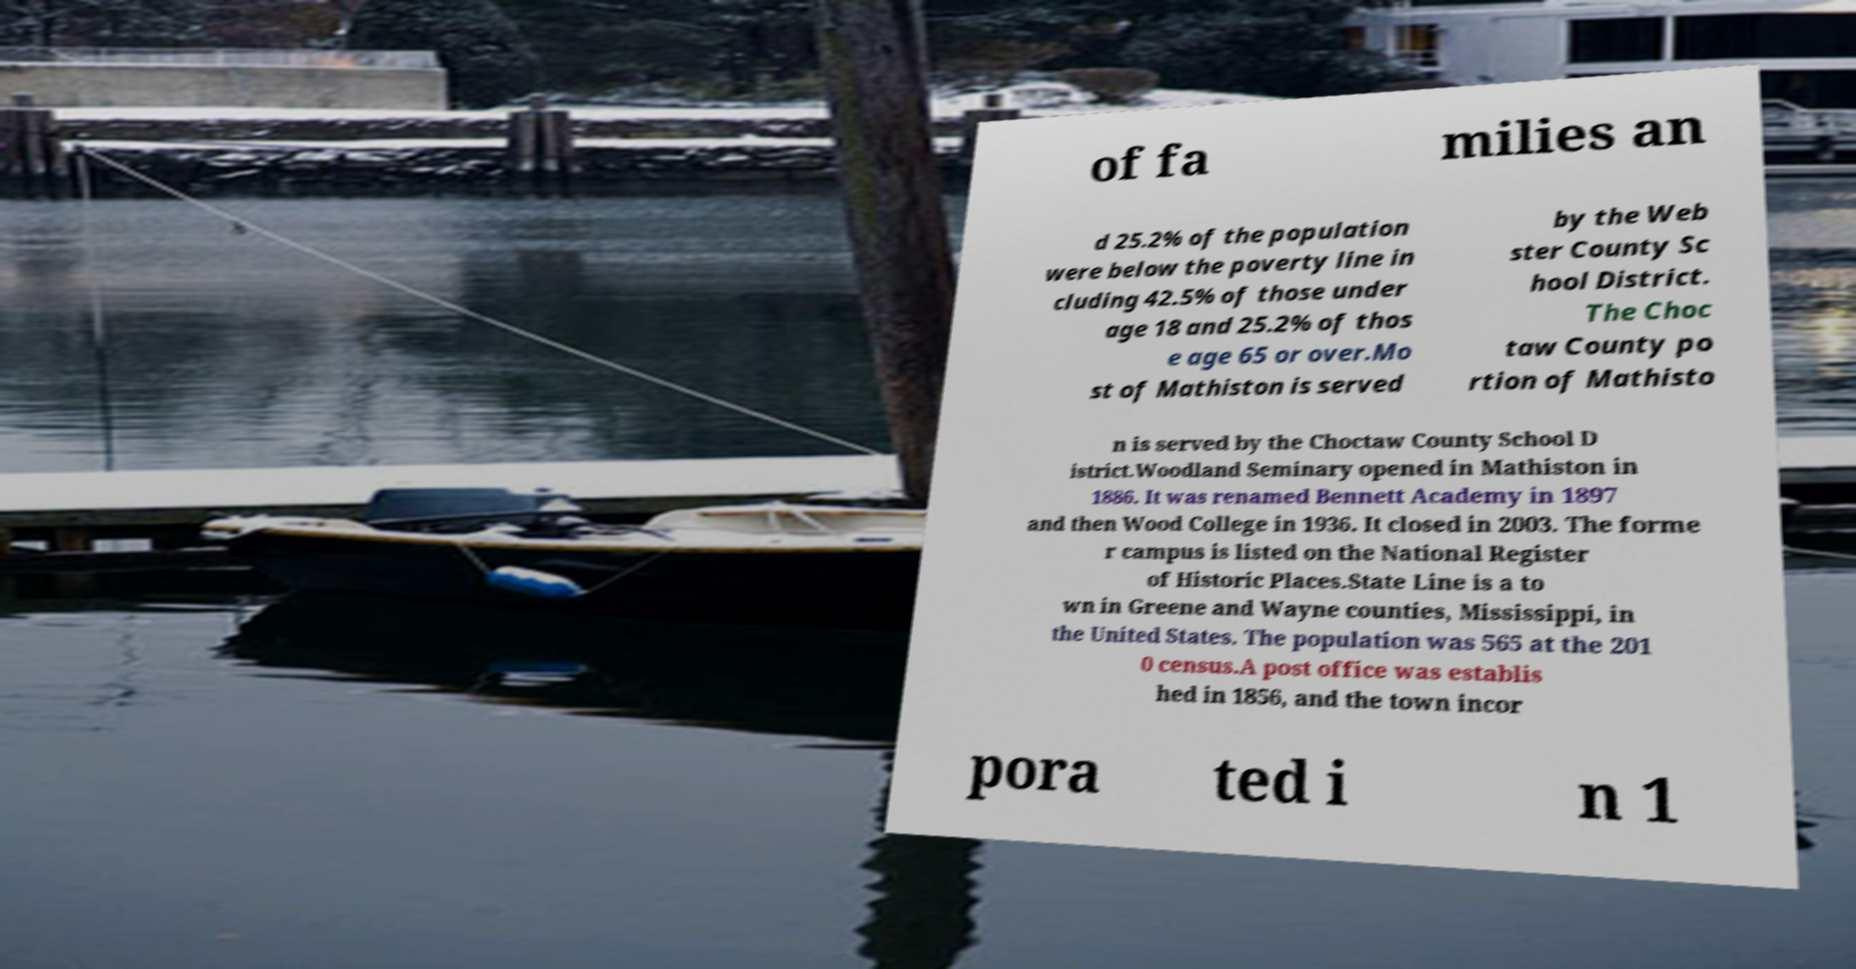Can you read and provide the text displayed in the image?This photo seems to have some interesting text. Can you extract and type it out for me? of fa milies an d 25.2% of the population were below the poverty line in cluding 42.5% of those under age 18 and 25.2% of thos e age 65 or over.Mo st of Mathiston is served by the Web ster County Sc hool District. The Choc taw County po rtion of Mathisto n is served by the Choctaw County School D istrict.Woodland Seminary opened in Mathiston in 1886. It was renamed Bennett Academy in 1897 and then Wood College in 1936. It closed in 2003. The forme r campus is listed on the National Register of Historic Places.State Line is a to wn in Greene and Wayne counties, Mississippi, in the United States. The population was 565 at the 201 0 census.A post office was establis hed in 1856, and the town incor pora ted i n 1 